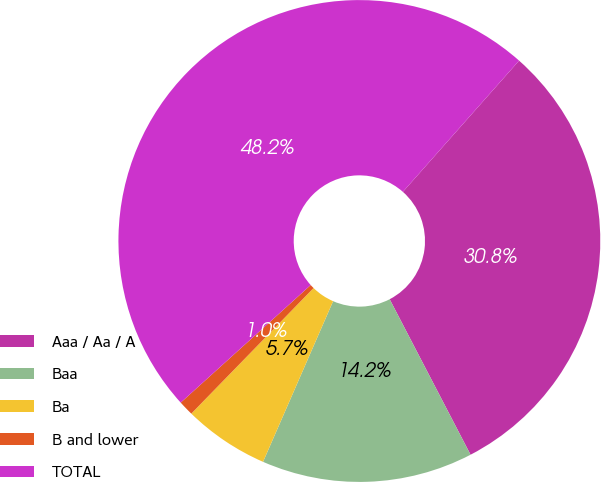Convert chart. <chart><loc_0><loc_0><loc_500><loc_500><pie_chart><fcel>Aaa / Aa / A<fcel>Baa<fcel>Ba<fcel>B and lower<fcel>TOTAL<nl><fcel>30.83%<fcel>14.18%<fcel>5.74%<fcel>1.01%<fcel>48.24%<nl></chart> 